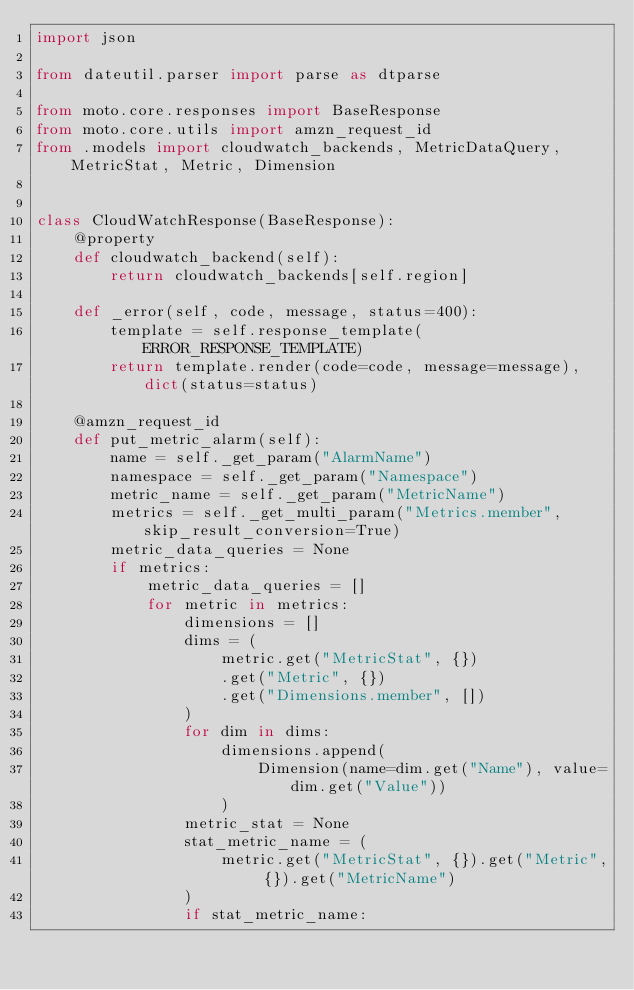<code> <loc_0><loc_0><loc_500><loc_500><_Python_>import json

from dateutil.parser import parse as dtparse

from moto.core.responses import BaseResponse
from moto.core.utils import amzn_request_id
from .models import cloudwatch_backends, MetricDataQuery, MetricStat, Metric, Dimension


class CloudWatchResponse(BaseResponse):
    @property
    def cloudwatch_backend(self):
        return cloudwatch_backends[self.region]

    def _error(self, code, message, status=400):
        template = self.response_template(ERROR_RESPONSE_TEMPLATE)
        return template.render(code=code, message=message), dict(status=status)

    @amzn_request_id
    def put_metric_alarm(self):
        name = self._get_param("AlarmName")
        namespace = self._get_param("Namespace")
        metric_name = self._get_param("MetricName")
        metrics = self._get_multi_param("Metrics.member", skip_result_conversion=True)
        metric_data_queries = None
        if metrics:
            metric_data_queries = []
            for metric in metrics:
                dimensions = []
                dims = (
                    metric.get("MetricStat", {})
                    .get("Metric", {})
                    .get("Dimensions.member", [])
                )
                for dim in dims:
                    dimensions.append(
                        Dimension(name=dim.get("Name"), value=dim.get("Value"))
                    )
                metric_stat = None
                stat_metric_name = (
                    metric.get("MetricStat", {}).get("Metric", {}).get("MetricName")
                )
                if stat_metric_name:</code> 